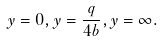Convert formula to latex. <formula><loc_0><loc_0><loc_500><loc_500>y = 0 , y = \frac { q } { 4 b } , y = \infty .</formula> 